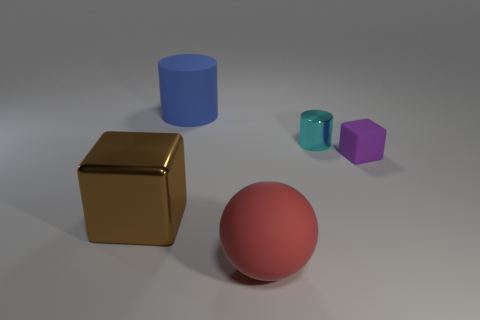Add 1 large brown metallic things. How many objects exist? 6 Subtract all balls. How many objects are left? 4 Add 5 tiny cyan objects. How many tiny cyan objects are left? 6 Add 1 purple rubber blocks. How many purple rubber blocks exist? 2 Subtract 1 brown blocks. How many objects are left? 4 Subtract all gray blocks. Subtract all red balls. How many blocks are left? 2 Subtract all large brown metallic blocks. Subtract all big red matte balls. How many objects are left? 3 